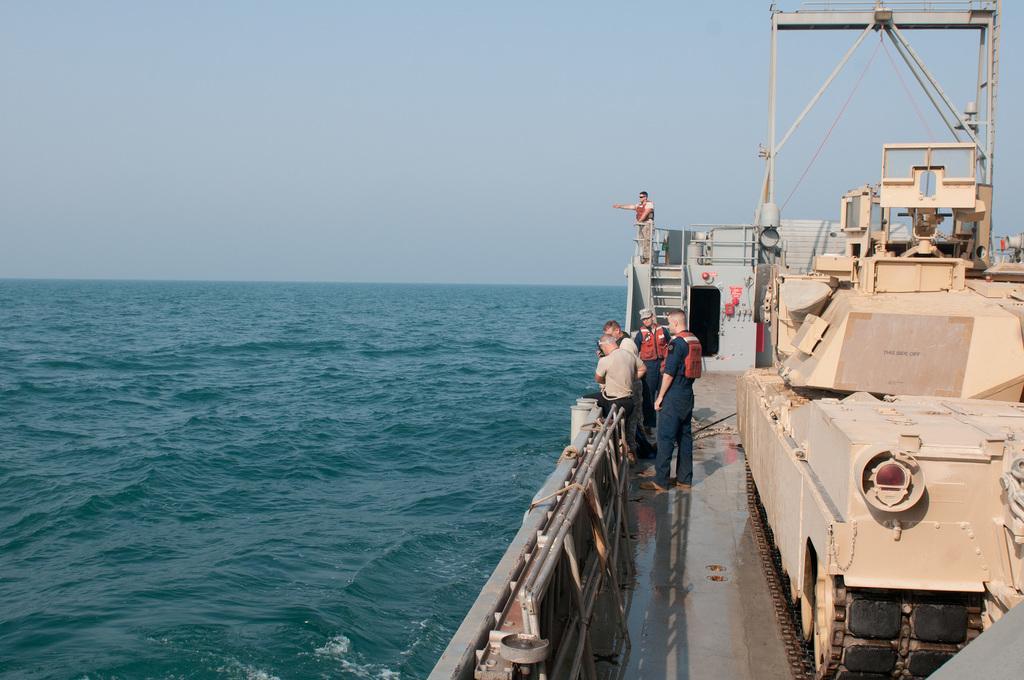How would you summarize this image in a sentence or two? On the right side of the image we can see persons in a ship. In the background there is water and sky. 